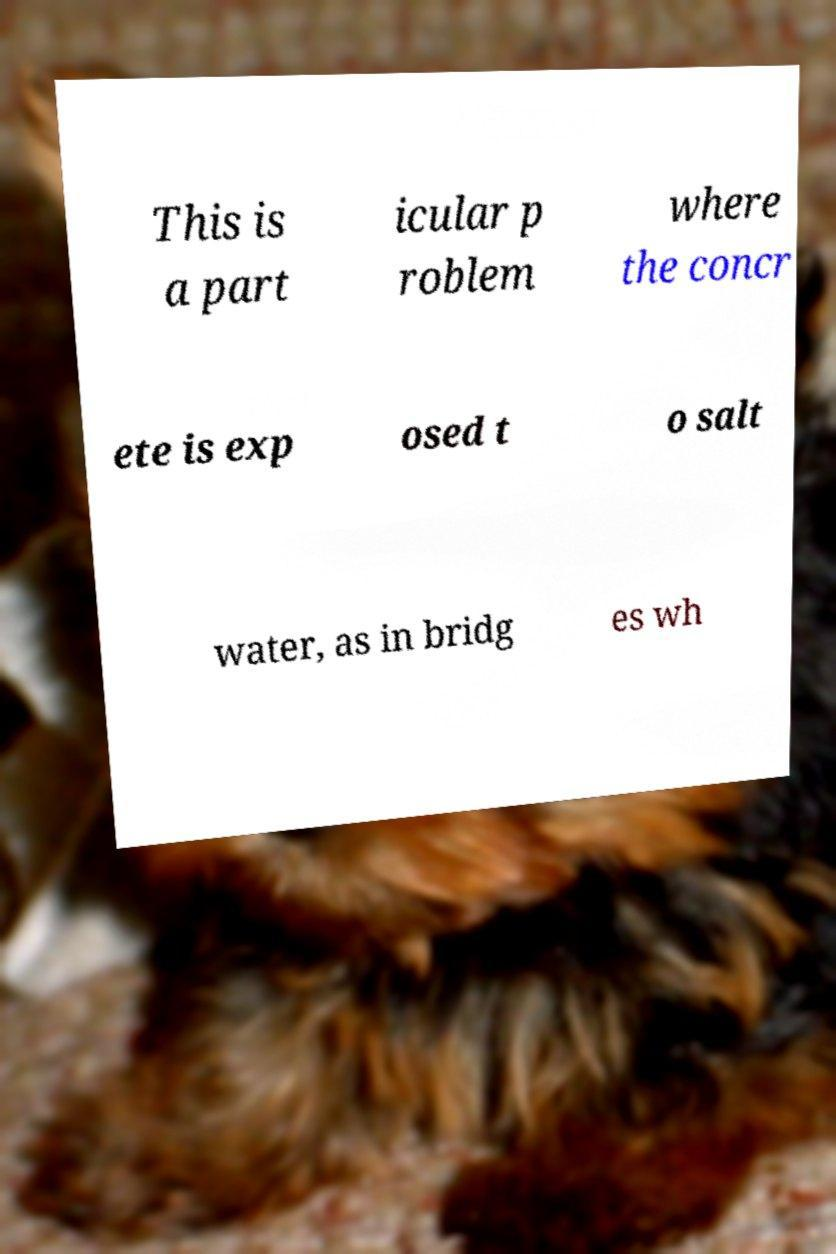There's text embedded in this image that I need extracted. Can you transcribe it verbatim? This is a part icular p roblem where the concr ete is exp osed t o salt water, as in bridg es wh 